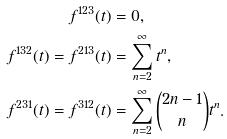Convert formula to latex. <formula><loc_0><loc_0><loc_500><loc_500>f ^ { 1 2 3 } ( t ) & = 0 , \\ f ^ { 1 3 2 } ( t ) = f ^ { 2 1 3 } ( t ) & = \sum _ { n = 2 } ^ { \infty } t ^ { n } , \\ f ^ { 2 3 1 } ( t ) = f ^ { 3 1 2 } ( t ) & = \sum _ { n = 2 } ^ { \infty } \binom { 2 n - 1 } { n } t ^ { n } .</formula> 